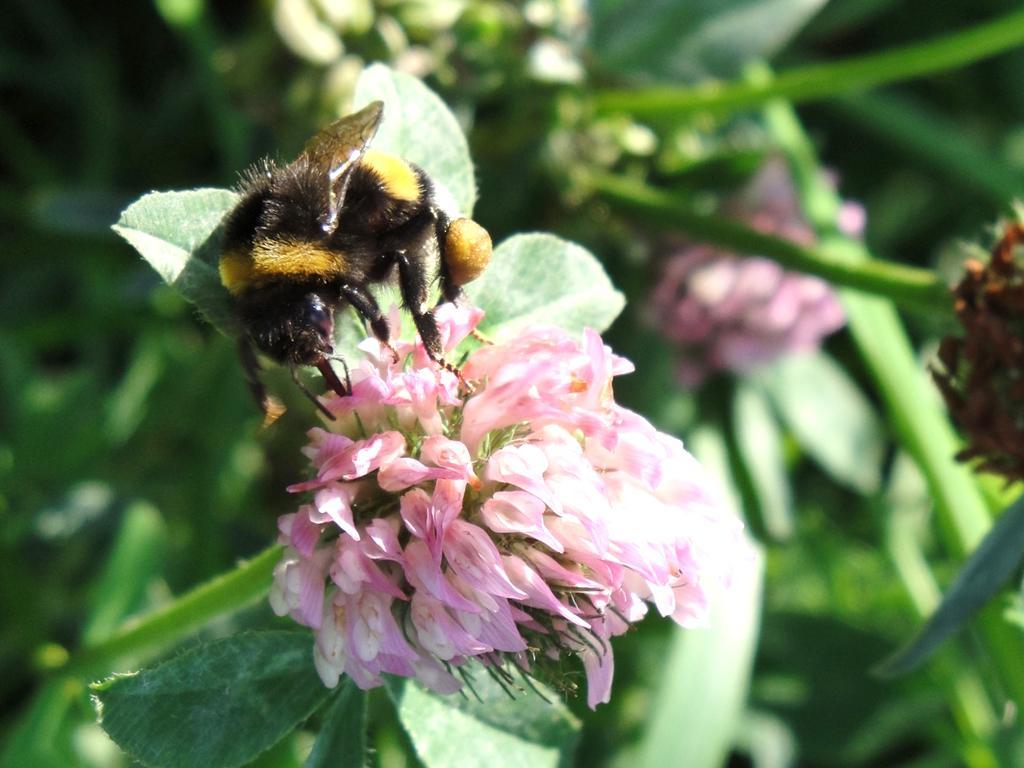Please provide a concise description of this image. In this picture we can see flowers and leaves, on the left side there is a honey bee, we can see a blurry background. 